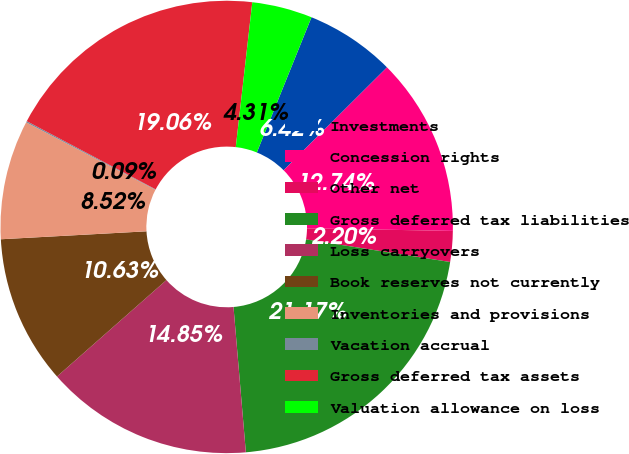Convert chart to OTSL. <chart><loc_0><loc_0><loc_500><loc_500><pie_chart><fcel>Investments<fcel>Concession rights<fcel>Other net<fcel>Gross deferred tax liabilities<fcel>Loss carryovers<fcel>Book reserves not currently<fcel>Inventories and provisions<fcel>Vacation accrual<fcel>Gross deferred tax assets<fcel>Valuation allowance on loss<nl><fcel>6.42%<fcel>12.74%<fcel>2.2%<fcel>21.17%<fcel>14.85%<fcel>10.63%<fcel>8.52%<fcel>0.09%<fcel>19.06%<fcel>4.31%<nl></chart> 